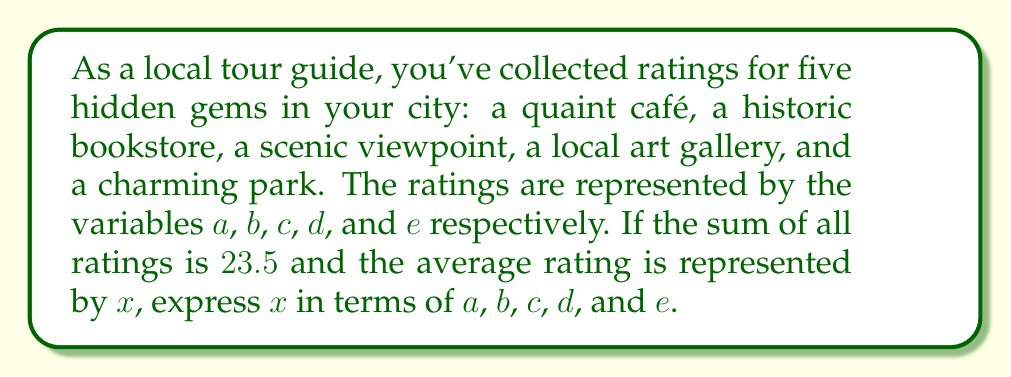Teach me how to tackle this problem. To solve this problem, we'll follow these steps:

1) First, recall that the average is calculated by dividing the sum of all values by the number of values.

2) We're given that the sum of all ratings is 23.5, so we can write:

   $a + b + c + d + e = 23.5$

3) We're also told that there are five attractions, so the average $x$ would be:

   $x = \frac{a + b + c + d + e}{5}$

4) We can substitute the sum we know from step 2 into this equation:

   $x = \frac{23.5}{5}$

5) Simplifying this fraction:

   $x = 4.7$

Therefore, the average rating $x$ can be expressed as $4.7$, or more explicitly in terms of the variables as:

$x = \frac{a + b + c + d + e}{5}$
Answer: $x = \frac{a + b + c + d + e}{5} = 4.7$ 